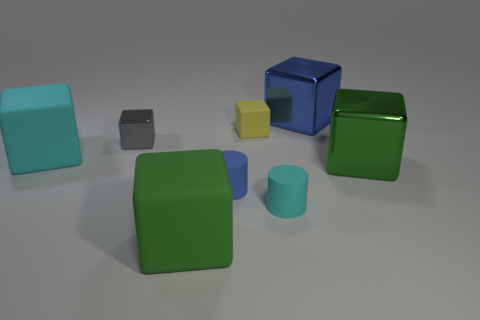Is there anything else that is the same color as the small shiny object?
Offer a very short reply. No. What is the color of the other large metal thing that is the same shape as the blue metal thing?
Offer a terse response. Green. Are there more big objects that are left of the blue shiny cube than gray cubes?
Your response must be concise. Yes. There is a shiny thing that is on the left side of the large blue thing; what color is it?
Keep it short and to the point. Gray. Is the size of the blue matte cylinder the same as the green rubber cube?
Your answer should be very brief. No. The yellow rubber block has what size?
Make the answer very short. Small. Is the number of big green matte objects greater than the number of tiny cylinders?
Offer a terse response. No. What is the color of the big block that is in front of the cyan matte object in front of the big shiny cube in front of the large blue metal object?
Ensure brevity in your answer.  Green. There is a matte object to the left of the green rubber object; is it the same shape as the blue rubber thing?
Provide a short and direct response. No. What color is the other metallic block that is the same size as the green shiny block?
Keep it short and to the point. Blue. 